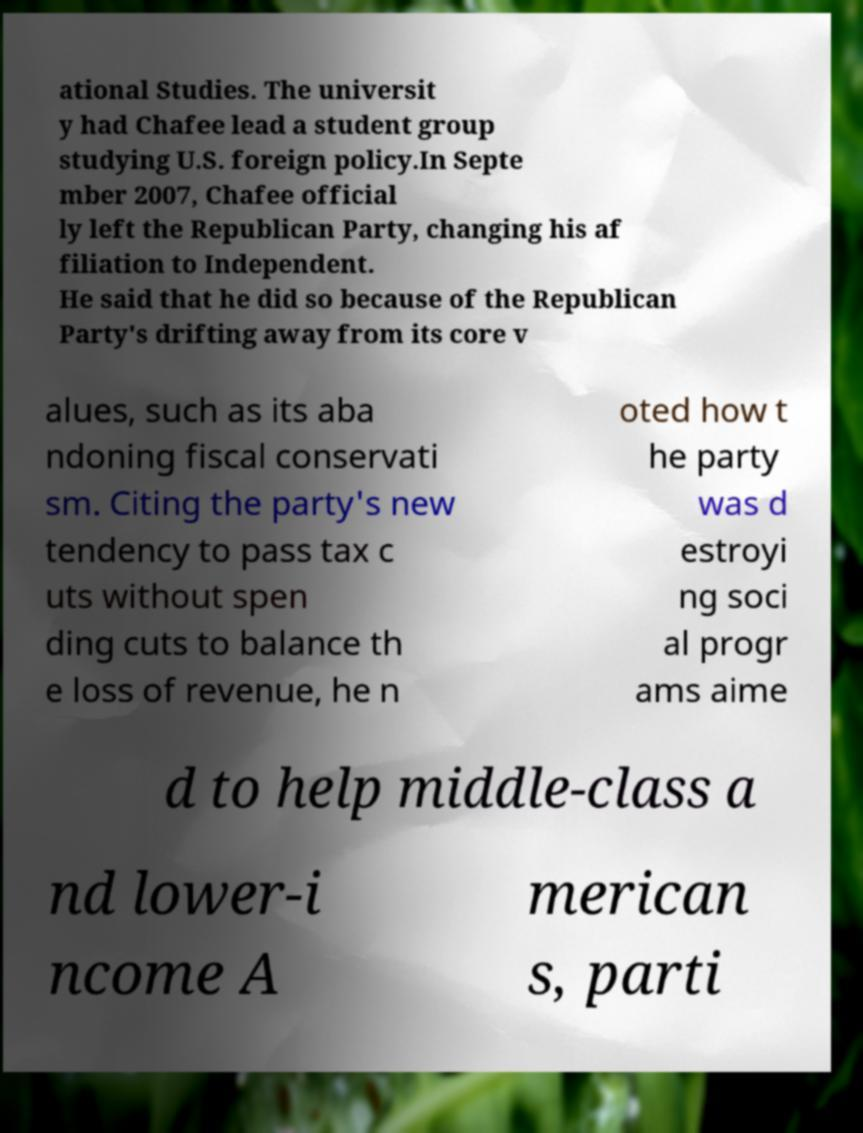Can you read and provide the text displayed in the image?This photo seems to have some interesting text. Can you extract and type it out for me? ational Studies. The universit y had Chafee lead a student group studying U.S. foreign policy.In Septe mber 2007, Chafee official ly left the Republican Party, changing his af filiation to Independent. He said that he did so because of the Republican Party's drifting away from its core v alues, such as its aba ndoning fiscal conservati sm. Citing the party's new tendency to pass tax c uts without spen ding cuts to balance th e loss of revenue, he n oted how t he party was d estroyi ng soci al progr ams aime d to help middle-class a nd lower-i ncome A merican s, parti 